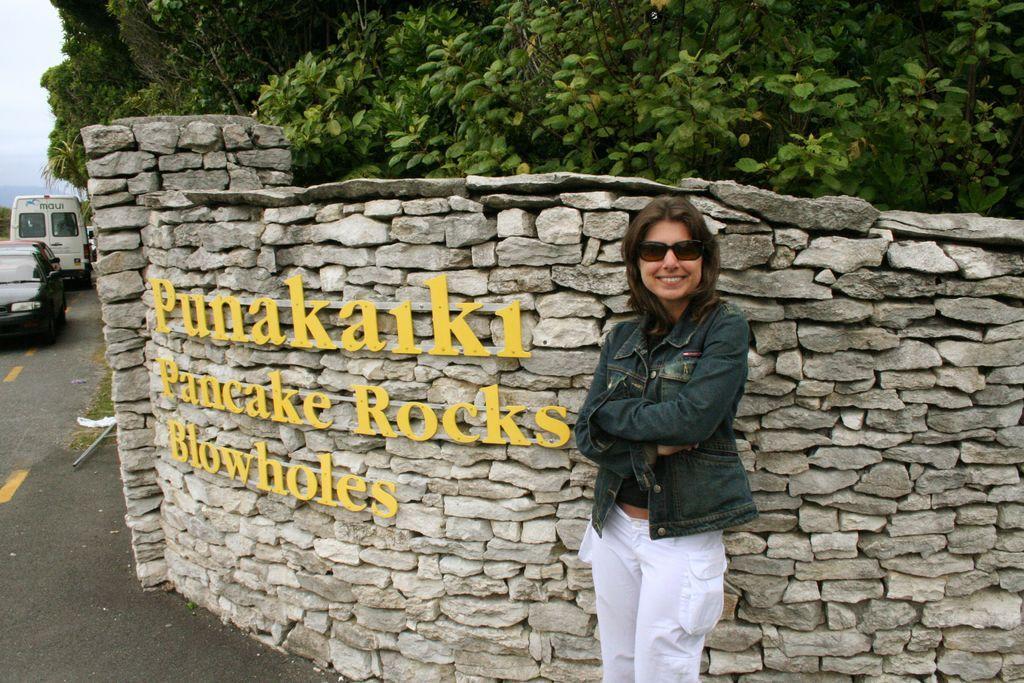Can you describe this image briefly? This image is taken outdoors. At the top of the image there are many trees with green leaves. On the left side of the image there is a sky with clouds and a few a cars are moving on the road. In the middle of the image there is a wall with stones and a text on it. A woman is standing on the road and she is with a smiling face. 